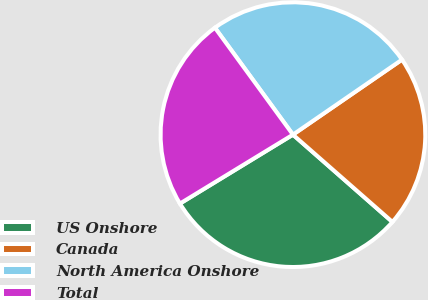<chart> <loc_0><loc_0><loc_500><loc_500><pie_chart><fcel>US Onshore<fcel>Canada<fcel>North America Onshore<fcel>Total<nl><fcel>29.82%<fcel>21.05%<fcel>25.44%<fcel>23.68%<nl></chart> 